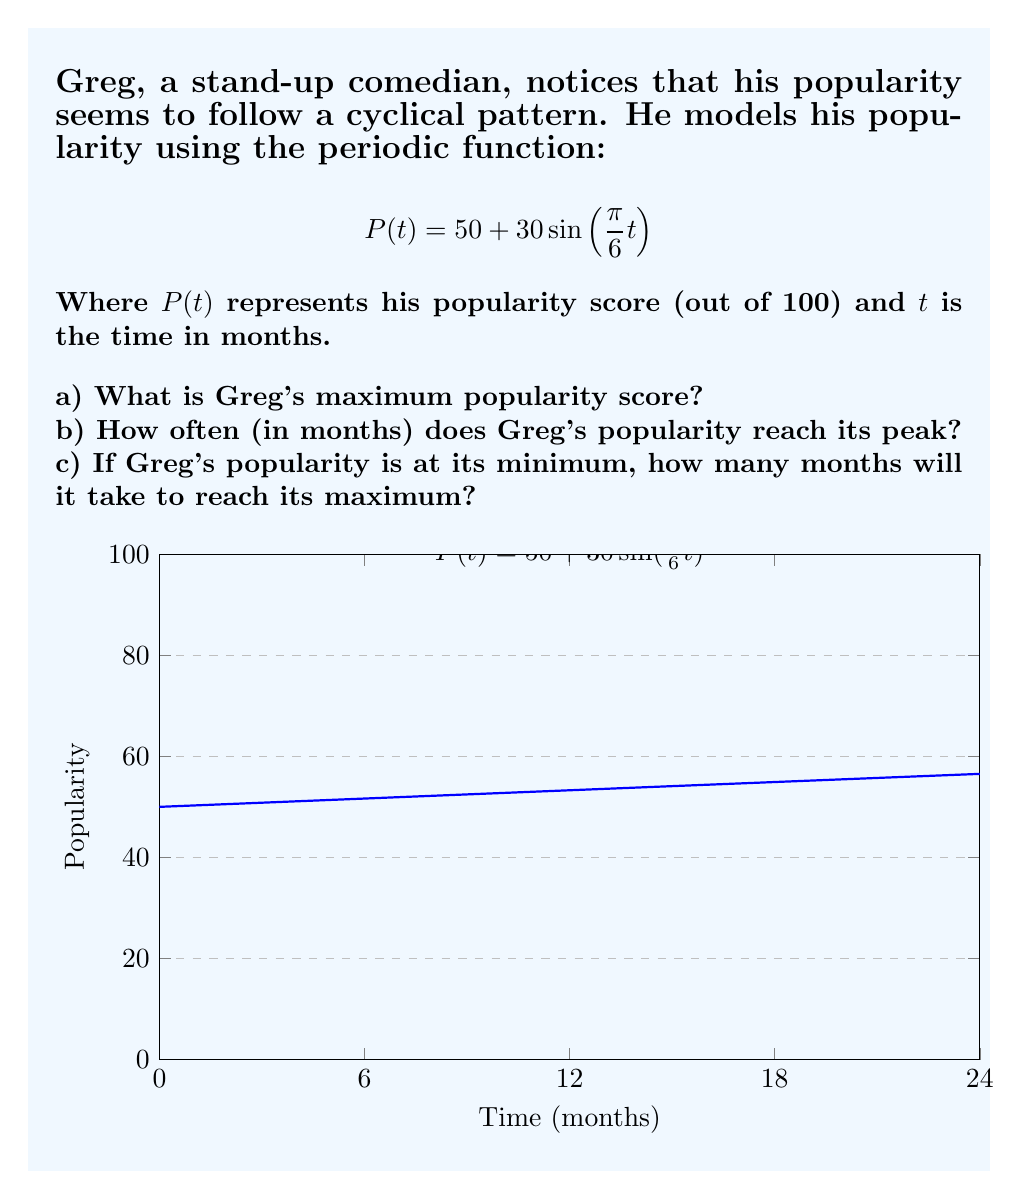Teach me how to tackle this problem. Let's approach this step-by-step:

a) To find the maximum popularity score:
   The sine function oscillates between -1 and 1.
   When $\sin(\frac{\pi}{6}t) = 1$, $P(t)$ will be at its maximum.
   $$P_{max} = 50 + 30(1) = 80$$

b) To find the period (how often the popularity peaks):
   The general form of a sine function is $a\sin(bt)$, where the period is $\frac{2\pi}{|b|}$.
   In this case, $b = \frac{\pi}{6}$
   Period $= \frac{2\pi}{|\frac{\pi}{6}|} = 12$ months

c) To find how long it takes to go from minimum to maximum:
   The sine function takes half a period to go from its minimum to its maximum.
   Half of the period we found in (b) is:
   $$\frac{12}{2} = 6$$ months

Therefore, it takes 6 months to go from minimum to maximum popularity.
Answer: a) 80
b) 12 months
c) 6 months 